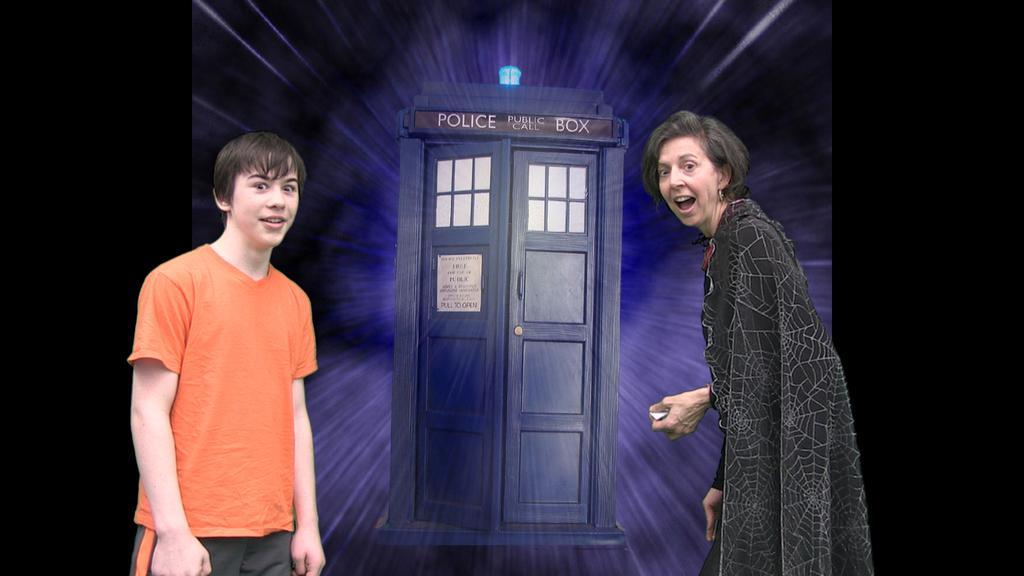Can you describe this image briefly? This is an edited picture. I can see two persons standing, and in the background it is looking like a board. 